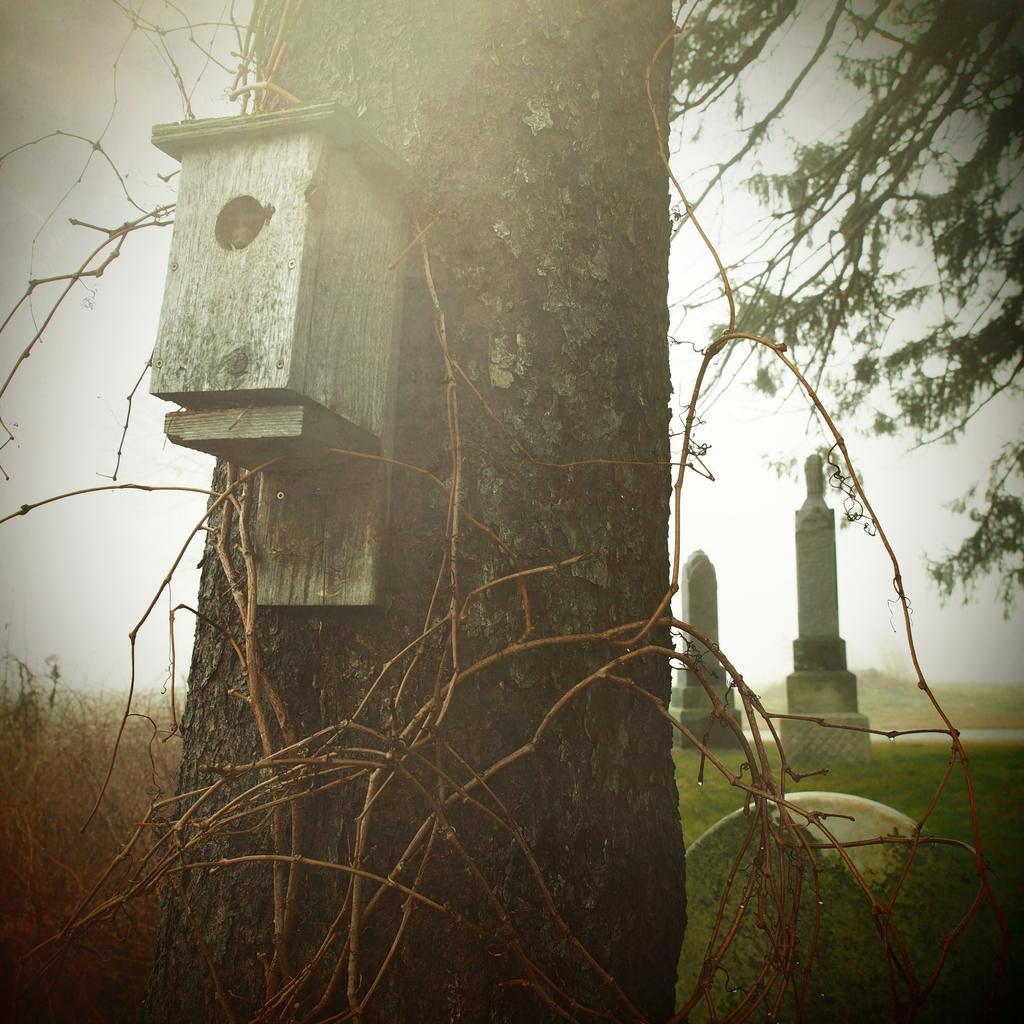In one or two sentences, can you explain what this image depicts? In this image there is a box attached to the trunk of the tree, there are a few stone pillars and few plants. 